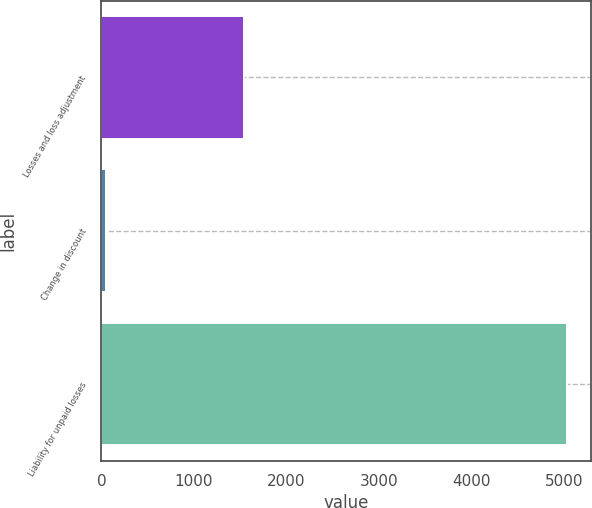Convert chart. <chart><loc_0><loc_0><loc_500><loc_500><bar_chart><fcel>Losses and loss adjustment<fcel>Change in discount<fcel>Liability for unpaid losses<nl><fcel>1545.6<fcel>51<fcel>5033<nl></chart> 